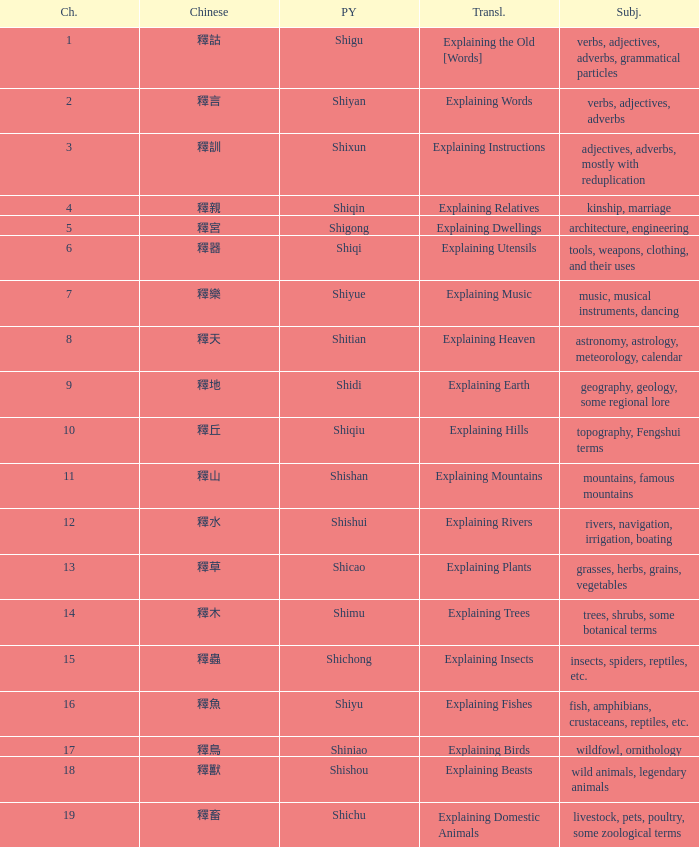Name the chinese with subject of adjectives, adverbs, mostly with reduplication 釋訓. 